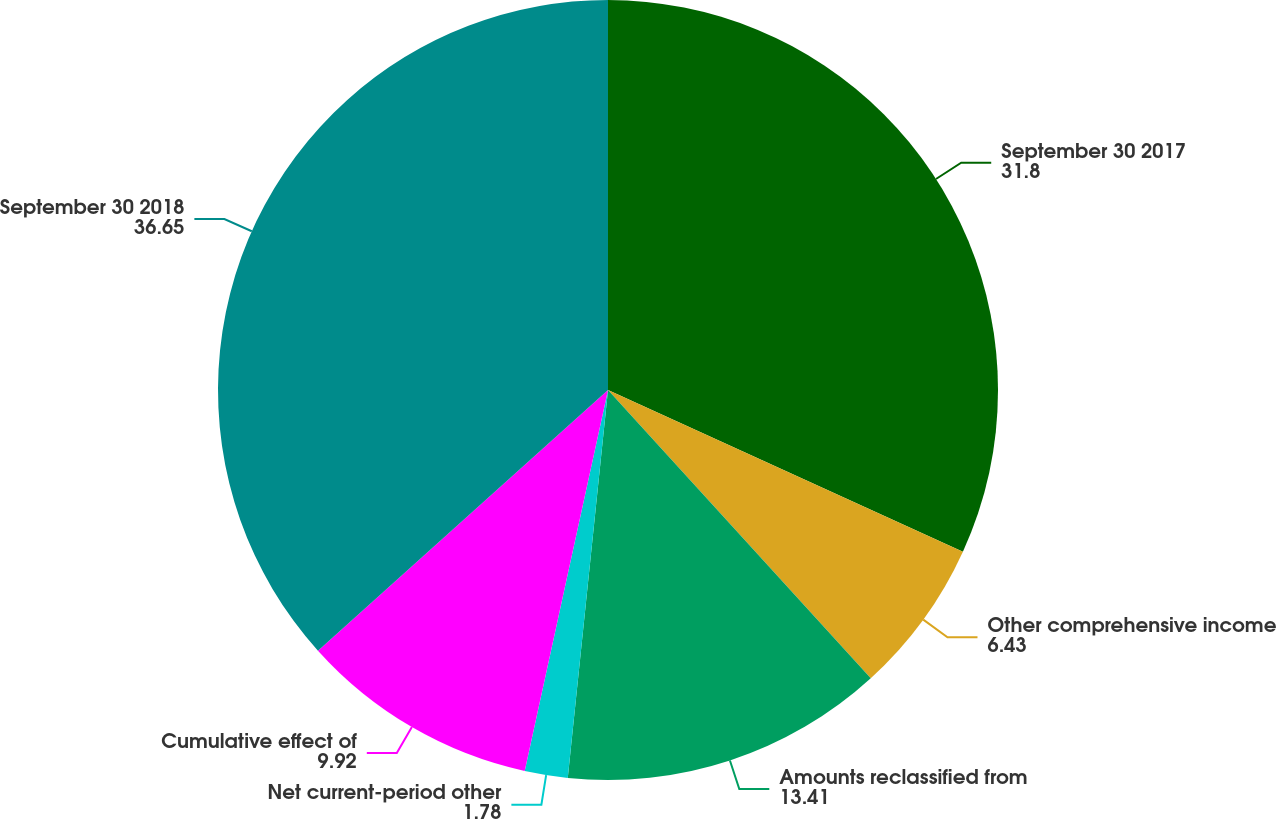Convert chart. <chart><loc_0><loc_0><loc_500><loc_500><pie_chart><fcel>September 30 2017<fcel>Other comprehensive income<fcel>Amounts reclassified from<fcel>Net current-period other<fcel>Cumulative effect of<fcel>September 30 2018<nl><fcel>31.8%<fcel>6.43%<fcel>13.41%<fcel>1.78%<fcel>9.92%<fcel>36.65%<nl></chart> 